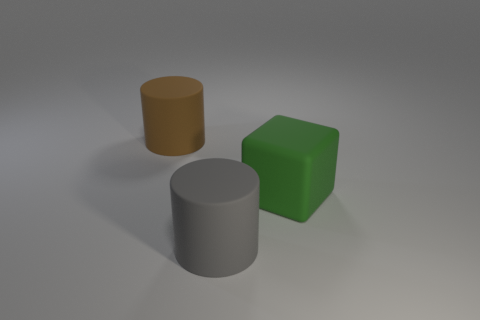Add 2 large brown rubber cylinders. How many objects exist? 5 Subtract all cubes. How many objects are left? 2 Add 3 gray rubber things. How many gray rubber things exist? 4 Subtract 0 green cylinders. How many objects are left? 3 Subtract all blue metal spheres. Subtract all green cubes. How many objects are left? 2 Add 3 brown matte objects. How many brown matte objects are left? 4 